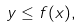<formula> <loc_0><loc_0><loc_500><loc_500>y \leq f ( x ) ,</formula> 